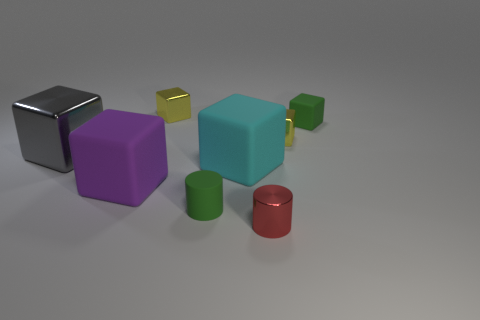Add 1 brown matte things. How many objects exist? 9 Subtract all small green matte cubes. How many cubes are left? 5 Subtract all gray blocks. How many blocks are left? 5 Subtract all blocks. How many objects are left? 2 Subtract 0 brown cylinders. How many objects are left? 8 Subtract 1 cylinders. How many cylinders are left? 1 Subtract all purple cubes. Subtract all cyan spheres. How many cubes are left? 5 Subtract all blue spheres. How many purple cylinders are left? 0 Subtract all small yellow shiny objects. Subtract all metal objects. How many objects are left? 2 Add 2 green objects. How many green objects are left? 4 